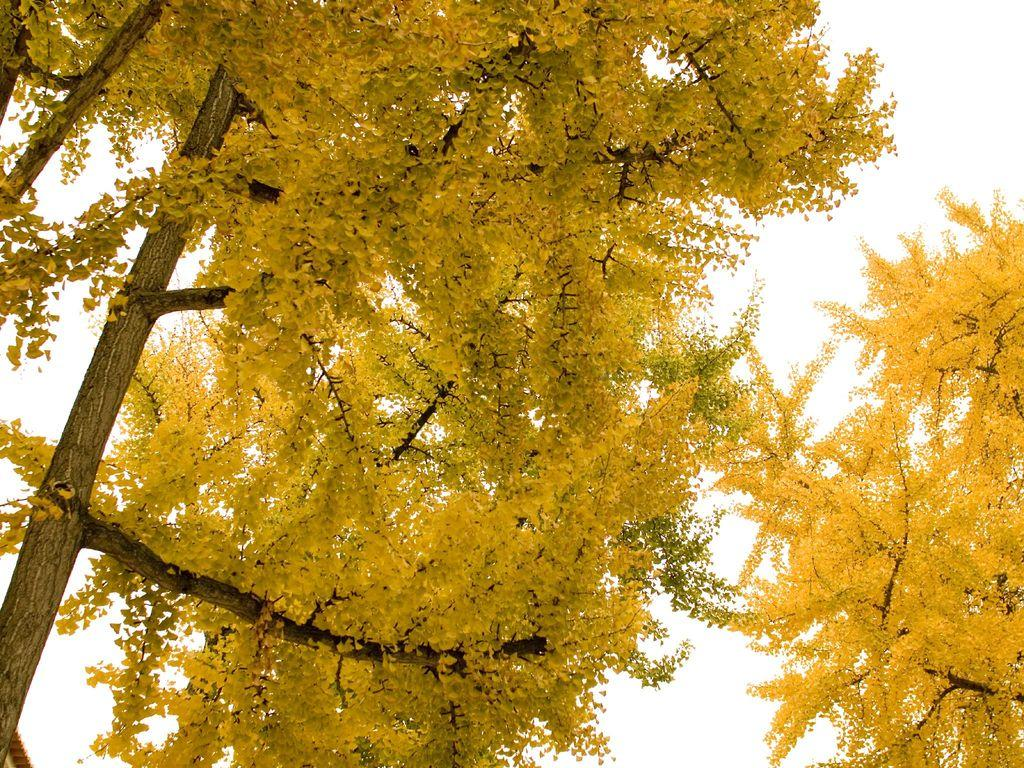How many trees are present in the image? There are two trees in the image. What color are the trees? The trees are yellow in color. What can be seen in the background of the image? The background of the image is white. What type of downtown area can be seen in the image? There is no downtown area present in the image; it features two yellow trees against a white background. 